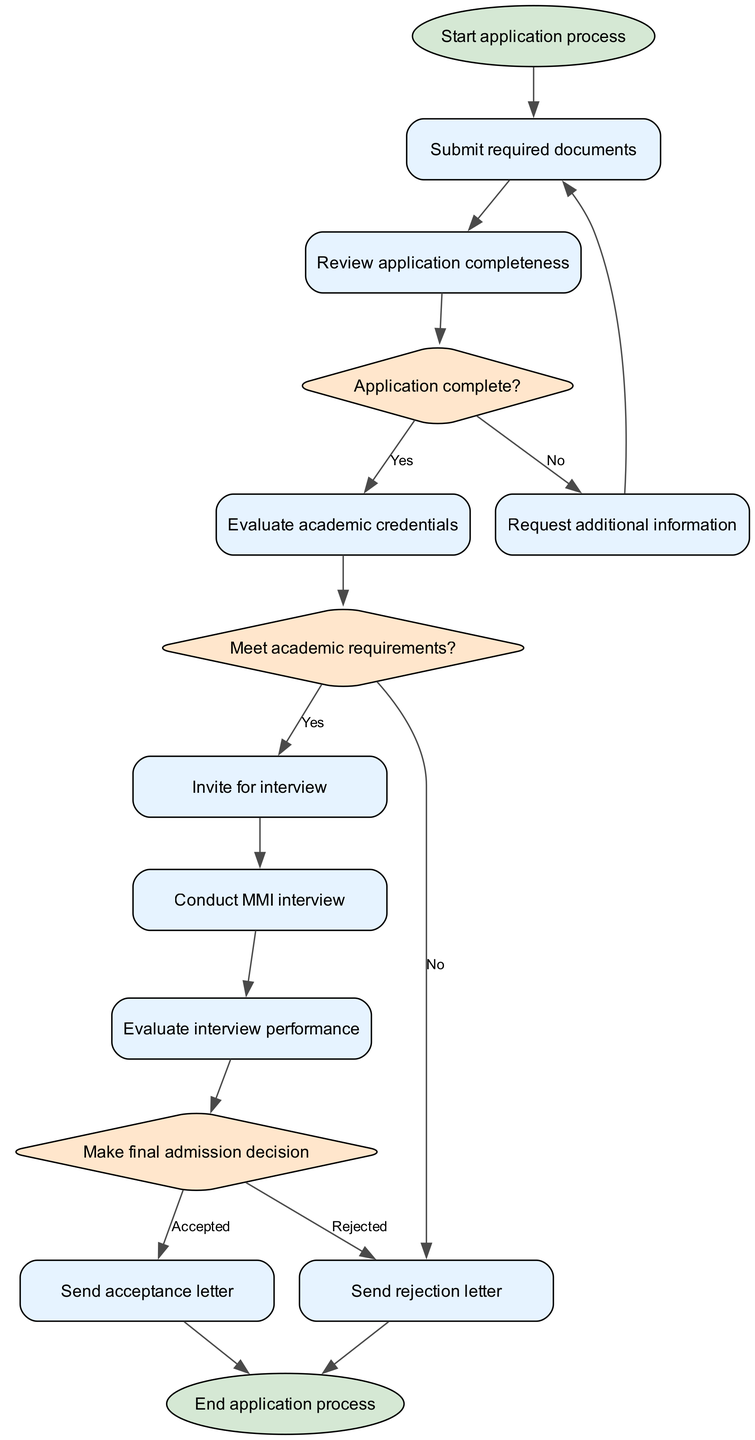What is the first step in the application process? The diagram starts with the "Start application process" node, which is the first element in the flowchart.
Answer: Start application process How many decision points are present in the application process? By examining the diagram, there are three decision points: "Application complete?", "Meet academic requirements?", and "Make final admission decision".
Answer: Three What happens if the application is incomplete? If the application is deemed incomplete, the flowchart directs to the "Request additional information" node, indicating that further documentation is necessary before proceeding.
Answer: Request additional information What is the outcome if an applicant does not meet academic requirements? The flowchart specifies that if an applicant does not meet the academic requirements, the outcome is to "Send rejection letter", thus terminating the application process for that candidate.
Answer: Send rejection letter How many acceptance outcomes exist in the final decision stage? The final decision stage has two outcomes: "Send acceptance letter" and "Send rejection letter", showing the possible results after evaluating the application and interview performance.
Answer: Two If an applicant is invited for an interview, what is the next step? After being invited for the interview, the flowchart indicates that the next step is to "Conduct MMI interview", highlighting the sequential nature of the process.
Answer: Conduct MMI interview What leads to the final admission decision? The path to the "Make final admission decision" node includes evaluating the interview performance following the "Conduct MMI interview" node, demonstrating that both document review and interview evaluations are critical.
Answer: Evaluate interview performance What does the flowchart suggest if the applicant is accepted? According to the flowchart, if accepted, the subsequent action is to "Send acceptance letter", confirming that the applicant has successfully passed all stages of evaluation.
Answer: Send acceptance letter 